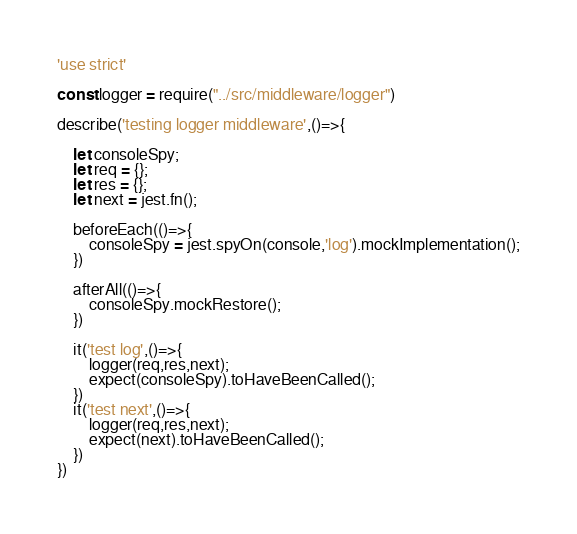<code> <loc_0><loc_0><loc_500><loc_500><_JavaScript_>'use strict'

const logger = require("../src/middleware/logger")

describe('testing logger middleware',()=>{

    let consoleSpy;
    let req = {};
    let res = {};
    let next = jest.fn();

    beforeEach(()=>{
        consoleSpy = jest.spyOn(console,'log').mockImplementation();
    })

    afterAll(()=>{
        consoleSpy.mockRestore();
    })

    it('test log',()=>{
        logger(req,res,next);
        expect(consoleSpy).toHaveBeenCalled();
    })
    it('test next',()=>{
        logger(req,res,next);
        expect(next).toHaveBeenCalled();
    })
})</code> 